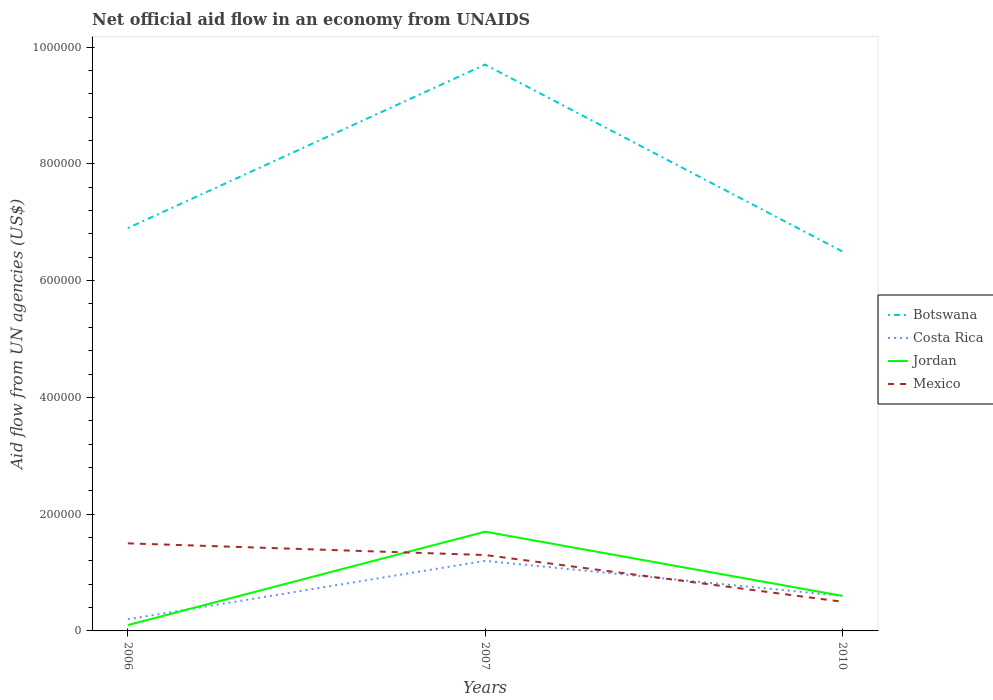Across all years, what is the maximum net official aid flow in Mexico?
Provide a short and direct response. 5.00e+04. In which year was the net official aid flow in Costa Rica maximum?
Provide a succinct answer. 2006. What is the total net official aid flow in Botswana in the graph?
Ensure brevity in your answer.  3.20e+05. What is the difference between the highest and the second highest net official aid flow in Botswana?
Your answer should be compact. 3.20e+05. What is the difference between the highest and the lowest net official aid flow in Botswana?
Ensure brevity in your answer.  1. Is the net official aid flow in Costa Rica strictly greater than the net official aid flow in Botswana over the years?
Give a very brief answer. Yes. How many lines are there?
Your response must be concise. 4. How many years are there in the graph?
Make the answer very short. 3. How are the legend labels stacked?
Your answer should be very brief. Vertical. What is the title of the graph?
Your response must be concise. Net official aid flow in an economy from UNAIDS. Does "Argentina" appear as one of the legend labels in the graph?
Make the answer very short. No. What is the label or title of the X-axis?
Provide a short and direct response. Years. What is the label or title of the Y-axis?
Provide a succinct answer. Aid flow from UN agencies (US$). What is the Aid flow from UN agencies (US$) of Botswana in 2006?
Provide a short and direct response. 6.90e+05. What is the Aid flow from UN agencies (US$) of Costa Rica in 2006?
Provide a short and direct response. 2.00e+04. What is the Aid flow from UN agencies (US$) of Mexico in 2006?
Make the answer very short. 1.50e+05. What is the Aid flow from UN agencies (US$) of Botswana in 2007?
Your answer should be compact. 9.70e+05. What is the Aid flow from UN agencies (US$) of Costa Rica in 2007?
Offer a terse response. 1.20e+05. What is the Aid flow from UN agencies (US$) in Botswana in 2010?
Your response must be concise. 6.50e+05. What is the Aid flow from UN agencies (US$) of Jordan in 2010?
Offer a terse response. 6.00e+04. Across all years, what is the maximum Aid flow from UN agencies (US$) of Botswana?
Your answer should be compact. 9.70e+05. Across all years, what is the maximum Aid flow from UN agencies (US$) of Costa Rica?
Offer a very short reply. 1.20e+05. Across all years, what is the maximum Aid flow from UN agencies (US$) in Mexico?
Your answer should be very brief. 1.50e+05. Across all years, what is the minimum Aid flow from UN agencies (US$) of Botswana?
Provide a succinct answer. 6.50e+05. What is the total Aid flow from UN agencies (US$) in Botswana in the graph?
Keep it short and to the point. 2.31e+06. What is the total Aid flow from UN agencies (US$) of Costa Rica in the graph?
Your answer should be compact. 2.00e+05. What is the total Aid flow from UN agencies (US$) of Jordan in the graph?
Your answer should be compact. 2.40e+05. What is the total Aid flow from UN agencies (US$) of Mexico in the graph?
Your answer should be compact. 3.30e+05. What is the difference between the Aid flow from UN agencies (US$) in Botswana in 2006 and that in 2007?
Ensure brevity in your answer.  -2.80e+05. What is the difference between the Aid flow from UN agencies (US$) of Costa Rica in 2006 and that in 2007?
Your response must be concise. -1.00e+05. What is the difference between the Aid flow from UN agencies (US$) in Costa Rica in 2006 and that in 2010?
Offer a very short reply. -4.00e+04. What is the difference between the Aid flow from UN agencies (US$) in Jordan in 2006 and that in 2010?
Your answer should be compact. -5.00e+04. What is the difference between the Aid flow from UN agencies (US$) of Mexico in 2006 and that in 2010?
Offer a terse response. 1.00e+05. What is the difference between the Aid flow from UN agencies (US$) of Botswana in 2007 and that in 2010?
Your response must be concise. 3.20e+05. What is the difference between the Aid flow from UN agencies (US$) of Costa Rica in 2007 and that in 2010?
Provide a short and direct response. 6.00e+04. What is the difference between the Aid flow from UN agencies (US$) of Jordan in 2007 and that in 2010?
Provide a short and direct response. 1.10e+05. What is the difference between the Aid flow from UN agencies (US$) of Botswana in 2006 and the Aid flow from UN agencies (US$) of Costa Rica in 2007?
Provide a succinct answer. 5.70e+05. What is the difference between the Aid flow from UN agencies (US$) in Botswana in 2006 and the Aid flow from UN agencies (US$) in Jordan in 2007?
Keep it short and to the point. 5.20e+05. What is the difference between the Aid flow from UN agencies (US$) of Botswana in 2006 and the Aid flow from UN agencies (US$) of Mexico in 2007?
Your answer should be compact. 5.60e+05. What is the difference between the Aid flow from UN agencies (US$) of Costa Rica in 2006 and the Aid flow from UN agencies (US$) of Mexico in 2007?
Your answer should be compact. -1.10e+05. What is the difference between the Aid flow from UN agencies (US$) in Jordan in 2006 and the Aid flow from UN agencies (US$) in Mexico in 2007?
Ensure brevity in your answer.  -1.20e+05. What is the difference between the Aid flow from UN agencies (US$) in Botswana in 2006 and the Aid flow from UN agencies (US$) in Costa Rica in 2010?
Ensure brevity in your answer.  6.30e+05. What is the difference between the Aid flow from UN agencies (US$) in Botswana in 2006 and the Aid flow from UN agencies (US$) in Jordan in 2010?
Give a very brief answer. 6.30e+05. What is the difference between the Aid flow from UN agencies (US$) in Botswana in 2006 and the Aid flow from UN agencies (US$) in Mexico in 2010?
Give a very brief answer. 6.40e+05. What is the difference between the Aid flow from UN agencies (US$) in Costa Rica in 2006 and the Aid flow from UN agencies (US$) in Jordan in 2010?
Give a very brief answer. -4.00e+04. What is the difference between the Aid flow from UN agencies (US$) in Botswana in 2007 and the Aid flow from UN agencies (US$) in Costa Rica in 2010?
Your answer should be compact. 9.10e+05. What is the difference between the Aid flow from UN agencies (US$) in Botswana in 2007 and the Aid flow from UN agencies (US$) in Jordan in 2010?
Offer a very short reply. 9.10e+05. What is the difference between the Aid flow from UN agencies (US$) of Botswana in 2007 and the Aid flow from UN agencies (US$) of Mexico in 2010?
Give a very brief answer. 9.20e+05. What is the difference between the Aid flow from UN agencies (US$) of Costa Rica in 2007 and the Aid flow from UN agencies (US$) of Mexico in 2010?
Provide a short and direct response. 7.00e+04. What is the average Aid flow from UN agencies (US$) of Botswana per year?
Provide a short and direct response. 7.70e+05. What is the average Aid flow from UN agencies (US$) in Costa Rica per year?
Your response must be concise. 6.67e+04. What is the average Aid flow from UN agencies (US$) in Mexico per year?
Your answer should be compact. 1.10e+05. In the year 2006, what is the difference between the Aid flow from UN agencies (US$) in Botswana and Aid flow from UN agencies (US$) in Costa Rica?
Provide a short and direct response. 6.70e+05. In the year 2006, what is the difference between the Aid flow from UN agencies (US$) in Botswana and Aid flow from UN agencies (US$) in Jordan?
Provide a succinct answer. 6.80e+05. In the year 2006, what is the difference between the Aid flow from UN agencies (US$) of Botswana and Aid flow from UN agencies (US$) of Mexico?
Give a very brief answer. 5.40e+05. In the year 2006, what is the difference between the Aid flow from UN agencies (US$) in Costa Rica and Aid flow from UN agencies (US$) in Jordan?
Keep it short and to the point. 10000. In the year 2006, what is the difference between the Aid flow from UN agencies (US$) in Jordan and Aid flow from UN agencies (US$) in Mexico?
Provide a short and direct response. -1.40e+05. In the year 2007, what is the difference between the Aid flow from UN agencies (US$) in Botswana and Aid flow from UN agencies (US$) in Costa Rica?
Your answer should be compact. 8.50e+05. In the year 2007, what is the difference between the Aid flow from UN agencies (US$) in Botswana and Aid flow from UN agencies (US$) in Jordan?
Keep it short and to the point. 8.00e+05. In the year 2007, what is the difference between the Aid flow from UN agencies (US$) of Botswana and Aid flow from UN agencies (US$) of Mexico?
Keep it short and to the point. 8.40e+05. In the year 2010, what is the difference between the Aid flow from UN agencies (US$) of Botswana and Aid flow from UN agencies (US$) of Costa Rica?
Provide a short and direct response. 5.90e+05. In the year 2010, what is the difference between the Aid flow from UN agencies (US$) of Botswana and Aid flow from UN agencies (US$) of Jordan?
Your answer should be compact. 5.90e+05. In the year 2010, what is the difference between the Aid flow from UN agencies (US$) in Botswana and Aid flow from UN agencies (US$) in Mexico?
Give a very brief answer. 6.00e+05. In the year 2010, what is the difference between the Aid flow from UN agencies (US$) of Costa Rica and Aid flow from UN agencies (US$) of Jordan?
Provide a succinct answer. 0. In the year 2010, what is the difference between the Aid flow from UN agencies (US$) of Jordan and Aid flow from UN agencies (US$) of Mexico?
Your answer should be very brief. 10000. What is the ratio of the Aid flow from UN agencies (US$) in Botswana in 2006 to that in 2007?
Offer a very short reply. 0.71. What is the ratio of the Aid flow from UN agencies (US$) in Costa Rica in 2006 to that in 2007?
Make the answer very short. 0.17. What is the ratio of the Aid flow from UN agencies (US$) in Jordan in 2006 to that in 2007?
Your response must be concise. 0.06. What is the ratio of the Aid flow from UN agencies (US$) of Mexico in 2006 to that in 2007?
Make the answer very short. 1.15. What is the ratio of the Aid flow from UN agencies (US$) in Botswana in 2006 to that in 2010?
Provide a succinct answer. 1.06. What is the ratio of the Aid flow from UN agencies (US$) in Jordan in 2006 to that in 2010?
Provide a succinct answer. 0.17. What is the ratio of the Aid flow from UN agencies (US$) of Mexico in 2006 to that in 2010?
Give a very brief answer. 3. What is the ratio of the Aid flow from UN agencies (US$) in Botswana in 2007 to that in 2010?
Make the answer very short. 1.49. What is the ratio of the Aid flow from UN agencies (US$) in Costa Rica in 2007 to that in 2010?
Provide a short and direct response. 2. What is the ratio of the Aid flow from UN agencies (US$) in Jordan in 2007 to that in 2010?
Ensure brevity in your answer.  2.83. What is the difference between the highest and the second highest Aid flow from UN agencies (US$) in Jordan?
Your answer should be very brief. 1.10e+05. What is the difference between the highest and the second highest Aid flow from UN agencies (US$) in Mexico?
Your response must be concise. 2.00e+04. What is the difference between the highest and the lowest Aid flow from UN agencies (US$) of Costa Rica?
Your response must be concise. 1.00e+05. What is the difference between the highest and the lowest Aid flow from UN agencies (US$) in Jordan?
Your response must be concise. 1.60e+05. 